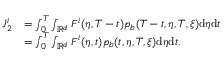<formula> <loc_0><loc_0><loc_500><loc_500>\begin{array} { r l } { J _ { 2 } ^ { i } } & { = \int _ { 0 } ^ { T } \int _ { \mathbb { R } ^ { d } } F ^ { i } ( \eta , T - t ) p _ { b } ( T - t , \eta , T , \xi ) d \eta d t } \\ & { = \int _ { 0 } ^ { T } \int _ { \mathbb { R } ^ { d } } F ^ { i } ( \eta , t ) p _ { b } ( t , \eta , T , \xi ) d \eta d t . } \end{array}</formula> 